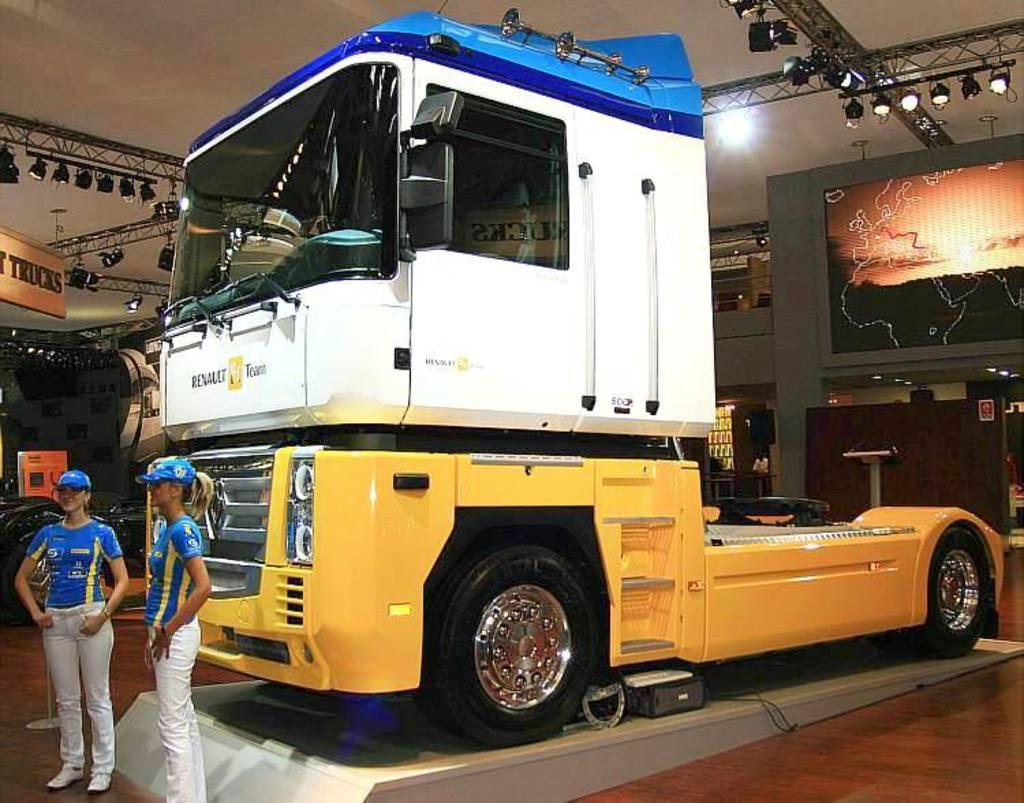How many women are in the image? There are two women in the image. What are the women wearing on their heads? The women are wearing blue caps. What can be seen in the image besides the women? There is a vehicle, lights, a screen, and a board visible in the image. Where is the baby playing with a goose in the image? There is no baby or goose present in the image. Is there a tent visible in the background of the image? No, there is no tent visible in the background of the image. 